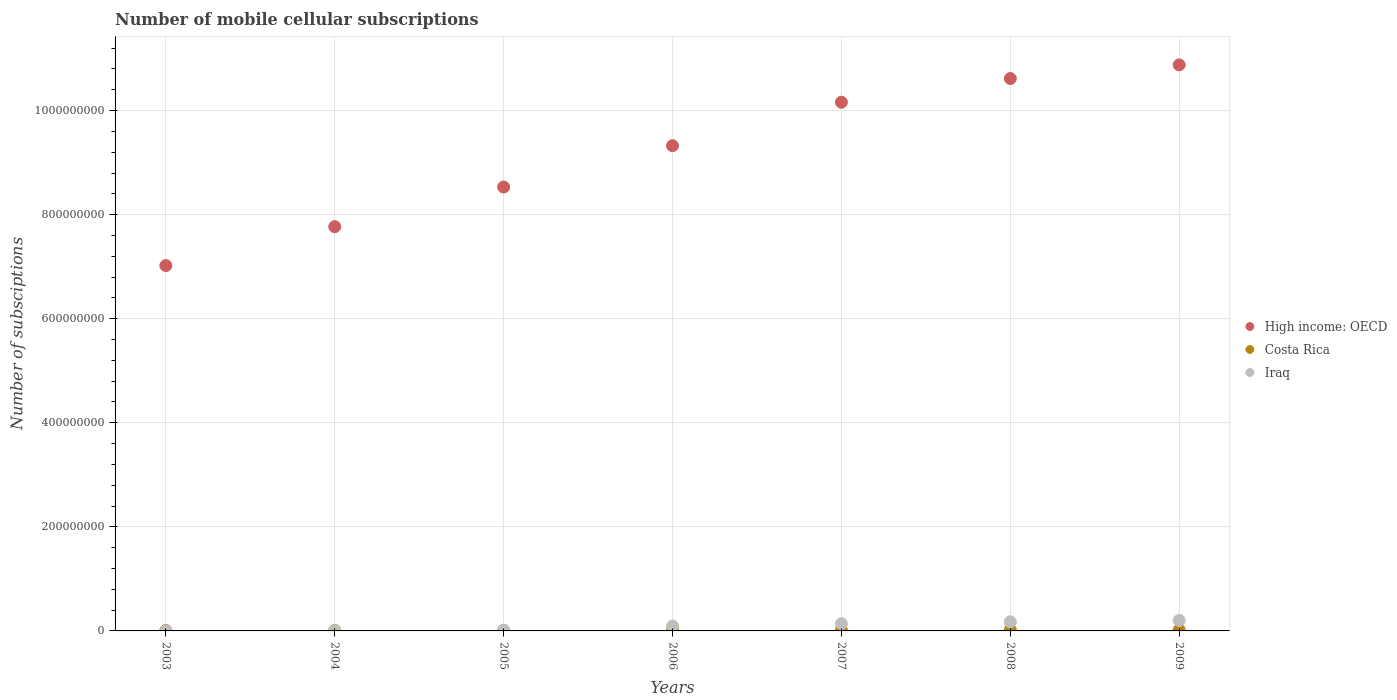What is the number of mobile cellular subscriptions in Costa Rica in 2005?
Give a very brief answer. 1.10e+06. Across all years, what is the maximum number of mobile cellular subscriptions in Iraq?
Keep it short and to the point. 2.01e+07. Across all years, what is the minimum number of mobile cellular subscriptions in Costa Rica?
Your response must be concise. 7.78e+05. In which year was the number of mobile cellular subscriptions in Iraq minimum?
Provide a short and direct response. 2003. What is the total number of mobile cellular subscriptions in High income: OECD in the graph?
Keep it short and to the point. 6.43e+09. What is the difference between the number of mobile cellular subscriptions in Iraq in 2004 and that in 2008?
Your answer should be very brief. -1.70e+07. What is the difference between the number of mobile cellular subscriptions in Iraq in 2003 and the number of mobile cellular subscriptions in Costa Rica in 2009?
Give a very brief answer. -1.87e+06. What is the average number of mobile cellular subscriptions in Iraq per year?
Offer a terse response. 9.03e+06. In the year 2007, what is the difference between the number of mobile cellular subscriptions in Iraq and number of mobile cellular subscriptions in High income: OECD?
Keep it short and to the point. -1.00e+09. What is the ratio of the number of mobile cellular subscriptions in Costa Rica in 2006 to that in 2008?
Ensure brevity in your answer.  0.77. Is the number of mobile cellular subscriptions in Iraq in 2003 less than that in 2006?
Provide a short and direct response. Yes. What is the difference between the highest and the second highest number of mobile cellular subscriptions in Iraq?
Offer a terse response. 2.59e+06. What is the difference between the highest and the lowest number of mobile cellular subscriptions in High income: OECD?
Your answer should be compact. 3.86e+08. Is it the case that in every year, the sum of the number of mobile cellular subscriptions in Costa Rica and number of mobile cellular subscriptions in Iraq  is greater than the number of mobile cellular subscriptions in High income: OECD?
Ensure brevity in your answer.  No. Does the number of mobile cellular subscriptions in Costa Rica monotonically increase over the years?
Ensure brevity in your answer.  Yes. Are the values on the major ticks of Y-axis written in scientific E-notation?
Your answer should be very brief. No. Does the graph contain grids?
Offer a very short reply. Yes. Where does the legend appear in the graph?
Make the answer very short. Center right. How many legend labels are there?
Make the answer very short. 3. What is the title of the graph?
Your answer should be very brief. Number of mobile cellular subscriptions. What is the label or title of the X-axis?
Your answer should be very brief. Years. What is the label or title of the Y-axis?
Your response must be concise. Number of subsciptions. What is the Number of subsciptions of High income: OECD in 2003?
Your answer should be very brief. 7.02e+08. What is the Number of subsciptions of Costa Rica in 2003?
Give a very brief answer. 7.78e+05. What is the Number of subsciptions of Iraq in 2003?
Provide a succinct answer. 8.00e+04. What is the Number of subsciptions in High income: OECD in 2004?
Your answer should be compact. 7.77e+08. What is the Number of subsciptions of Costa Rica in 2004?
Your answer should be compact. 9.23e+05. What is the Number of subsciptions in Iraq in 2004?
Make the answer very short. 5.74e+05. What is the Number of subsciptions in High income: OECD in 2005?
Keep it short and to the point. 8.53e+08. What is the Number of subsciptions of Costa Rica in 2005?
Provide a short and direct response. 1.10e+06. What is the Number of subsciptions in Iraq in 2005?
Your response must be concise. 1.53e+06. What is the Number of subsciptions in High income: OECD in 2006?
Your answer should be compact. 9.33e+08. What is the Number of subsciptions in Costa Rica in 2006?
Ensure brevity in your answer.  1.44e+06. What is the Number of subsciptions in Iraq in 2006?
Your answer should be compact. 9.35e+06. What is the Number of subsciptions in High income: OECD in 2007?
Offer a terse response. 1.02e+09. What is the Number of subsciptions of Costa Rica in 2007?
Keep it short and to the point. 1.51e+06. What is the Number of subsciptions of Iraq in 2007?
Your response must be concise. 1.40e+07. What is the Number of subsciptions of High income: OECD in 2008?
Your answer should be compact. 1.06e+09. What is the Number of subsciptions in Costa Rica in 2008?
Ensure brevity in your answer.  1.89e+06. What is the Number of subsciptions of Iraq in 2008?
Your answer should be very brief. 1.75e+07. What is the Number of subsciptions of High income: OECD in 2009?
Provide a succinct answer. 1.09e+09. What is the Number of subsciptions of Costa Rica in 2009?
Offer a very short reply. 1.95e+06. What is the Number of subsciptions in Iraq in 2009?
Your response must be concise. 2.01e+07. Across all years, what is the maximum Number of subsciptions of High income: OECD?
Make the answer very short. 1.09e+09. Across all years, what is the maximum Number of subsciptions in Costa Rica?
Your response must be concise. 1.95e+06. Across all years, what is the maximum Number of subsciptions in Iraq?
Keep it short and to the point. 2.01e+07. Across all years, what is the minimum Number of subsciptions of High income: OECD?
Ensure brevity in your answer.  7.02e+08. Across all years, what is the minimum Number of subsciptions of Costa Rica?
Provide a succinct answer. 7.78e+05. Across all years, what is the minimum Number of subsciptions of Iraq?
Your answer should be very brief. 8.00e+04. What is the total Number of subsciptions of High income: OECD in the graph?
Make the answer very short. 6.43e+09. What is the total Number of subsciptions of Costa Rica in the graph?
Ensure brevity in your answer.  9.59e+06. What is the total Number of subsciptions of Iraq in the graph?
Offer a very short reply. 6.32e+07. What is the difference between the Number of subsciptions of High income: OECD in 2003 and that in 2004?
Offer a very short reply. -7.48e+07. What is the difference between the Number of subsciptions of Costa Rica in 2003 and that in 2004?
Keep it short and to the point. -1.45e+05. What is the difference between the Number of subsciptions in Iraq in 2003 and that in 2004?
Offer a terse response. -4.94e+05. What is the difference between the Number of subsciptions in High income: OECD in 2003 and that in 2005?
Your answer should be very brief. -1.51e+08. What is the difference between the Number of subsciptions in Costa Rica in 2003 and that in 2005?
Ensure brevity in your answer.  -3.23e+05. What is the difference between the Number of subsciptions in Iraq in 2003 and that in 2005?
Ensure brevity in your answer.  -1.45e+06. What is the difference between the Number of subsciptions of High income: OECD in 2003 and that in 2006?
Keep it short and to the point. -2.30e+08. What is the difference between the Number of subsciptions of Costa Rica in 2003 and that in 2006?
Offer a very short reply. -6.65e+05. What is the difference between the Number of subsciptions of Iraq in 2003 and that in 2006?
Give a very brief answer. -9.27e+06. What is the difference between the Number of subsciptions in High income: OECD in 2003 and that in 2007?
Offer a terse response. -3.14e+08. What is the difference between the Number of subsciptions in Costa Rica in 2003 and that in 2007?
Ensure brevity in your answer.  -7.30e+05. What is the difference between the Number of subsciptions of Iraq in 2003 and that in 2007?
Keep it short and to the point. -1.39e+07. What is the difference between the Number of subsciptions in High income: OECD in 2003 and that in 2008?
Give a very brief answer. -3.59e+08. What is the difference between the Number of subsciptions in Costa Rica in 2003 and that in 2008?
Provide a short and direct response. -1.11e+06. What is the difference between the Number of subsciptions of Iraq in 2003 and that in 2008?
Keep it short and to the point. -1.74e+07. What is the difference between the Number of subsciptions of High income: OECD in 2003 and that in 2009?
Your response must be concise. -3.86e+08. What is the difference between the Number of subsciptions of Costa Rica in 2003 and that in 2009?
Keep it short and to the point. -1.17e+06. What is the difference between the Number of subsciptions in Iraq in 2003 and that in 2009?
Provide a short and direct response. -2.00e+07. What is the difference between the Number of subsciptions in High income: OECD in 2004 and that in 2005?
Keep it short and to the point. -7.62e+07. What is the difference between the Number of subsciptions of Costa Rica in 2004 and that in 2005?
Your answer should be compact. -1.78e+05. What is the difference between the Number of subsciptions in Iraq in 2004 and that in 2005?
Offer a very short reply. -9.59e+05. What is the difference between the Number of subsciptions of High income: OECD in 2004 and that in 2006?
Ensure brevity in your answer.  -1.56e+08. What is the difference between the Number of subsciptions in Costa Rica in 2004 and that in 2006?
Provide a short and direct response. -5.21e+05. What is the difference between the Number of subsciptions in Iraq in 2004 and that in 2006?
Keep it short and to the point. -8.77e+06. What is the difference between the Number of subsciptions in High income: OECD in 2004 and that in 2007?
Your answer should be compact. -2.39e+08. What is the difference between the Number of subsciptions of Costa Rica in 2004 and that in 2007?
Provide a short and direct response. -5.85e+05. What is the difference between the Number of subsciptions in Iraq in 2004 and that in 2007?
Your answer should be very brief. -1.34e+07. What is the difference between the Number of subsciptions in High income: OECD in 2004 and that in 2008?
Ensure brevity in your answer.  -2.85e+08. What is the difference between the Number of subsciptions in Costa Rica in 2004 and that in 2008?
Give a very brief answer. -9.63e+05. What is the difference between the Number of subsciptions in Iraq in 2004 and that in 2008?
Your answer should be very brief. -1.70e+07. What is the difference between the Number of subsciptions in High income: OECD in 2004 and that in 2009?
Offer a terse response. -3.11e+08. What is the difference between the Number of subsciptions of Costa Rica in 2004 and that in 2009?
Make the answer very short. -1.03e+06. What is the difference between the Number of subsciptions of Iraq in 2004 and that in 2009?
Give a very brief answer. -1.95e+07. What is the difference between the Number of subsciptions of High income: OECD in 2005 and that in 2006?
Offer a very short reply. -7.94e+07. What is the difference between the Number of subsciptions of Costa Rica in 2005 and that in 2006?
Your answer should be very brief. -3.42e+05. What is the difference between the Number of subsciptions of Iraq in 2005 and that in 2006?
Ensure brevity in your answer.  -7.81e+06. What is the difference between the Number of subsciptions in High income: OECD in 2005 and that in 2007?
Make the answer very short. -1.63e+08. What is the difference between the Number of subsciptions in Costa Rica in 2005 and that in 2007?
Ensure brevity in your answer.  -4.07e+05. What is the difference between the Number of subsciptions in Iraq in 2005 and that in 2007?
Keep it short and to the point. -1.25e+07. What is the difference between the Number of subsciptions of High income: OECD in 2005 and that in 2008?
Ensure brevity in your answer.  -2.09e+08. What is the difference between the Number of subsciptions in Costa Rica in 2005 and that in 2008?
Offer a terse response. -7.85e+05. What is the difference between the Number of subsciptions of Iraq in 2005 and that in 2008?
Keep it short and to the point. -1.60e+07. What is the difference between the Number of subsciptions of High income: OECD in 2005 and that in 2009?
Ensure brevity in your answer.  -2.35e+08. What is the difference between the Number of subsciptions in Costa Rica in 2005 and that in 2009?
Provide a short and direct response. -8.49e+05. What is the difference between the Number of subsciptions in Iraq in 2005 and that in 2009?
Your answer should be compact. -1.86e+07. What is the difference between the Number of subsciptions in High income: OECD in 2006 and that in 2007?
Your answer should be compact. -8.35e+07. What is the difference between the Number of subsciptions of Costa Rica in 2006 and that in 2007?
Offer a terse response. -6.45e+04. What is the difference between the Number of subsciptions of Iraq in 2006 and that in 2007?
Ensure brevity in your answer.  -4.68e+06. What is the difference between the Number of subsciptions in High income: OECD in 2006 and that in 2008?
Your answer should be compact. -1.29e+08. What is the difference between the Number of subsciptions in Costa Rica in 2006 and that in 2008?
Make the answer very short. -4.43e+05. What is the difference between the Number of subsciptions in Iraq in 2006 and that in 2008?
Your answer should be very brief. -8.18e+06. What is the difference between the Number of subsciptions of High income: OECD in 2006 and that in 2009?
Offer a terse response. -1.55e+08. What is the difference between the Number of subsciptions in Costa Rica in 2006 and that in 2009?
Provide a short and direct response. -5.07e+05. What is the difference between the Number of subsciptions of Iraq in 2006 and that in 2009?
Offer a very short reply. -1.08e+07. What is the difference between the Number of subsciptions of High income: OECD in 2007 and that in 2008?
Make the answer very short. -4.56e+07. What is the difference between the Number of subsciptions of Costa Rica in 2007 and that in 2008?
Offer a terse response. -3.78e+05. What is the difference between the Number of subsciptions of Iraq in 2007 and that in 2008?
Your answer should be compact. -3.51e+06. What is the difference between the Number of subsciptions of High income: OECD in 2007 and that in 2009?
Make the answer very short. -7.18e+07. What is the difference between the Number of subsciptions in Costa Rica in 2007 and that in 2009?
Offer a terse response. -4.42e+05. What is the difference between the Number of subsciptions of Iraq in 2007 and that in 2009?
Provide a short and direct response. -6.10e+06. What is the difference between the Number of subsciptions of High income: OECD in 2008 and that in 2009?
Provide a short and direct response. -2.62e+07. What is the difference between the Number of subsciptions of Costa Rica in 2008 and that in 2009?
Offer a terse response. -6.37e+04. What is the difference between the Number of subsciptions in Iraq in 2008 and that in 2009?
Your answer should be very brief. -2.59e+06. What is the difference between the Number of subsciptions of High income: OECD in 2003 and the Number of subsciptions of Costa Rica in 2004?
Ensure brevity in your answer.  7.01e+08. What is the difference between the Number of subsciptions in High income: OECD in 2003 and the Number of subsciptions in Iraq in 2004?
Provide a short and direct response. 7.02e+08. What is the difference between the Number of subsciptions of Costa Rica in 2003 and the Number of subsciptions of Iraq in 2004?
Keep it short and to the point. 2.04e+05. What is the difference between the Number of subsciptions of High income: OECD in 2003 and the Number of subsciptions of Costa Rica in 2005?
Your response must be concise. 7.01e+08. What is the difference between the Number of subsciptions in High income: OECD in 2003 and the Number of subsciptions in Iraq in 2005?
Provide a succinct answer. 7.01e+08. What is the difference between the Number of subsciptions of Costa Rica in 2003 and the Number of subsciptions of Iraq in 2005?
Provide a short and direct response. -7.55e+05. What is the difference between the Number of subsciptions in High income: OECD in 2003 and the Number of subsciptions in Costa Rica in 2006?
Offer a very short reply. 7.01e+08. What is the difference between the Number of subsciptions in High income: OECD in 2003 and the Number of subsciptions in Iraq in 2006?
Keep it short and to the point. 6.93e+08. What is the difference between the Number of subsciptions in Costa Rica in 2003 and the Number of subsciptions in Iraq in 2006?
Keep it short and to the point. -8.57e+06. What is the difference between the Number of subsciptions of High income: OECD in 2003 and the Number of subsciptions of Costa Rica in 2007?
Keep it short and to the point. 7.01e+08. What is the difference between the Number of subsciptions in High income: OECD in 2003 and the Number of subsciptions in Iraq in 2007?
Keep it short and to the point. 6.88e+08. What is the difference between the Number of subsciptions in Costa Rica in 2003 and the Number of subsciptions in Iraq in 2007?
Your response must be concise. -1.32e+07. What is the difference between the Number of subsciptions in High income: OECD in 2003 and the Number of subsciptions in Costa Rica in 2008?
Make the answer very short. 7.00e+08. What is the difference between the Number of subsciptions in High income: OECD in 2003 and the Number of subsciptions in Iraq in 2008?
Offer a very short reply. 6.85e+08. What is the difference between the Number of subsciptions of Costa Rica in 2003 and the Number of subsciptions of Iraq in 2008?
Your response must be concise. -1.68e+07. What is the difference between the Number of subsciptions in High income: OECD in 2003 and the Number of subsciptions in Costa Rica in 2009?
Offer a terse response. 7.00e+08. What is the difference between the Number of subsciptions in High income: OECD in 2003 and the Number of subsciptions in Iraq in 2009?
Your response must be concise. 6.82e+08. What is the difference between the Number of subsciptions in Costa Rica in 2003 and the Number of subsciptions in Iraq in 2009?
Your response must be concise. -1.93e+07. What is the difference between the Number of subsciptions of High income: OECD in 2004 and the Number of subsciptions of Costa Rica in 2005?
Your answer should be very brief. 7.76e+08. What is the difference between the Number of subsciptions of High income: OECD in 2004 and the Number of subsciptions of Iraq in 2005?
Offer a terse response. 7.75e+08. What is the difference between the Number of subsciptions of Costa Rica in 2004 and the Number of subsciptions of Iraq in 2005?
Provide a short and direct response. -6.10e+05. What is the difference between the Number of subsciptions of High income: OECD in 2004 and the Number of subsciptions of Costa Rica in 2006?
Keep it short and to the point. 7.76e+08. What is the difference between the Number of subsciptions of High income: OECD in 2004 and the Number of subsciptions of Iraq in 2006?
Offer a terse response. 7.68e+08. What is the difference between the Number of subsciptions in Costa Rica in 2004 and the Number of subsciptions in Iraq in 2006?
Provide a succinct answer. -8.42e+06. What is the difference between the Number of subsciptions in High income: OECD in 2004 and the Number of subsciptions in Costa Rica in 2007?
Provide a succinct answer. 7.75e+08. What is the difference between the Number of subsciptions in High income: OECD in 2004 and the Number of subsciptions in Iraq in 2007?
Your response must be concise. 7.63e+08. What is the difference between the Number of subsciptions of Costa Rica in 2004 and the Number of subsciptions of Iraq in 2007?
Your response must be concise. -1.31e+07. What is the difference between the Number of subsciptions in High income: OECD in 2004 and the Number of subsciptions in Costa Rica in 2008?
Provide a short and direct response. 7.75e+08. What is the difference between the Number of subsciptions in High income: OECD in 2004 and the Number of subsciptions in Iraq in 2008?
Your answer should be compact. 7.59e+08. What is the difference between the Number of subsciptions of Costa Rica in 2004 and the Number of subsciptions of Iraq in 2008?
Your answer should be compact. -1.66e+07. What is the difference between the Number of subsciptions of High income: OECD in 2004 and the Number of subsciptions of Costa Rica in 2009?
Offer a very short reply. 7.75e+08. What is the difference between the Number of subsciptions in High income: OECD in 2004 and the Number of subsciptions in Iraq in 2009?
Provide a short and direct response. 7.57e+08. What is the difference between the Number of subsciptions in Costa Rica in 2004 and the Number of subsciptions in Iraq in 2009?
Ensure brevity in your answer.  -1.92e+07. What is the difference between the Number of subsciptions in High income: OECD in 2005 and the Number of subsciptions in Costa Rica in 2006?
Provide a short and direct response. 8.52e+08. What is the difference between the Number of subsciptions in High income: OECD in 2005 and the Number of subsciptions in Iraq in 2006?
Your answer should be very brief. 8.44e+08. What is the difference between the Number of subsciptions of Costa Rica in 2005 and the Number of subsciptions of Iraq in 2006?
Ensure brevity in your answer.  -8.24e+06. What is the difference between the Number of subsciptions of High income: OECD in 2005 and the Number of subsciptions of Costa Rica in 2007?
Provide a short and direct response. 8.52e+08. What is the difference between the Number of subsciptions in High income: OECD in 2005 and the Number of subsciptions in Iraq in 2007?
Offer a terse response. 8.39e+08. What is the difference between the Number of subsciptions of Costa Rica in 2005 and the Number of subsciptions of Iraq in 2007?
Your response must be concise. -1.29e+07. What is the difference between the Number of subsciptions in High income: OECD in 2005 and the Number of subsciptions in Costa Rica in 2008?
Make the answer very short. 8.51e+08. What is the difference between the Number of subsciptions in High income: OECD in 2005 and the Number of subsciptions in Iraq in 2008?
Your answer should be very brief. 8.36e+08. What is the difference between the Number of subsciptions of Costa Rica in 2005 and the Number of subsciptions of Iraq in 2008?
Your answer should be very brief. -1.64e+07. What is the difference between the Number of subsciptions of High income: OECD in 2005 and the Number of subsciptions of Costa Rica in 2009?
Your response must be concise. 8.51e+08. What is the difference between the Number of subsciptions in High income: OECD in 2005 and the Number of subsciptions in Iraq in 2009?
Offer a terse response. 8.33e+08. What is the difference between the Number of subsciptions of Costa Rica in 2005 and the Number of subsciptions of Iraq in 2009?
Offer a terse response. -1.90e+07. What is the difference between the Number of subsciptions in High income: OECD in 2006 and the Number of subsciptions in Costa Rica in 2007?
Offer a very short reply. 9.31e+08. What is the difference between the Number of subsciptions of High income: OECD in 2006 and the Number of subsciptions of Iraq in 2007?
Offer a terse response. 9.19e+08. What is the difference between the Number of subsciptions of Costa Rica in 2006 and the Number of subsciptions of Iraq in 2007?
Give a very brief answer. -1.26e+07. What is the difference between the Number of subsciptions of High income: OECD in 2006 and the Number of subsciptions of Costa Rica in 2008?
Give a very brief answer. 9.31e+08. What is the difference between the Number of subsciptions of High income: OECD in 2006 and the Number of subsciptions of Iraq in 2008?
Offer a terse response. 9.15e+08. What is the difference between the Number of subsciptions in Costa Rica in 2006 and the Number of subsciptions in Iraq in 2008?
Offer a very short reply. -1.61e+07. What is the difference between the Number of subsciptions of High income: OECD in 2006 and the Number of subsciptions of Costa Rica in 2009?
Your answer should be very brief. 9.31e+08. What is the difference between the Number of subsciptions in High income: OECD in 2006 and the Number of subsciptions in Iraq in 2009?
Your answer should be compact. 9.12e+08. What is the difference between the Number of subsciptions of Costa Rica in 2006 and the Number of subsciptions of Iraq in 2009?
Make the answer very short. -1.87e+07. What is the difference between the Number of subsciptions of High income: OECD in 2007 and the Number of subsciptions of Costa Rica in 2008?
Provide a short and direct response. 1.01e+09. What is the difference between the Number of subsciptions in High income: OECD in 2007 and the Number of subsciptions in Iraq in 2008?
Provide a succinct answer. 9.99e+08. What is the difference between the Number of subsciptions of Costa Rica in 2007 and the Number of subsciptions of Iraq in 2008?
Keep it short and to the point. -1.60e+07. What is the difference between the Number of subsciptions in High income: OECD in 2007 and the Number of subsciptions in Costa Rica in 2009?
Provide a succinct answer. 1.01e+09. What is the difference between the Number of subsciptions of High income: OECD in 2007 and the Number of subsciptions of Iraq in 2009?
Offer a very short reply. 9.96e+08. What is the difference between the Number of subsciptions of Costa Rica in 2007 and the Number of subsciptions of Iraq in 2009?
Offer a very short reply. -1.86e+07. What is the difference between the Number of subsciptions of High income: OECD in 2008 and the Number of subsciptions of Costa Rica in 2009?
Provide a succinct answer. 1.06e+09. What is the difference between the Number of subsciptions in High income: OECD in 2008 and the Number of subsciptions in Iraq in 2009?
Make the answer very short. 1.04e+09. What is the difference between the Number of subsciptions of Costa Rica in 2008 and the Number of subsciptions of Iraq in 2009?
Offer a very short reply. -1.82e+07. What is the average Number of subsciptions in High income: OECD per year?
Provide a succinct answer. 9.19e+08. What is the average Number of subsciptions in Costa Rica per year?
Provide a short and direct response. 1.37e+06. What is the average Number of subsciptions of Iraq per year?
Your response must be concise. 9.03e+06. In the year 2003, what is the difference between the Number of subsciptions of High income: OECD and Number of subsciptions of Costa Rica?
Make the answer very short. 7.01e+08. In the year 2003, what is the difference between the Number of subsciptions in High income: OECD and Number of subsciptions in Iraq?
Offer a terse response. 7.02e+08. In the year 2003, what is the difference between the Number of subsciptions in Costa Rica and Number of subsciptions in Iraq?
Provide a succinct answer. 6.98e+05. In the year 2004, what is the difference between the Number of subsciptions in High income: OECD and Number of subsciptions in Costa Rica?
Ensure brevity in your answer.  7.76e+08. In the year 2004, what is the difference between the Number of subsciptions in High income: OECD and Number of subsciptions in Iraq?
Ensure brevity in your answer.  7.76e+08. In the year 2004, what is the difference between the Number of subsciptions of Costa Rica and Number of subsciptions of Iraq?
Your answer should be very brief. 3.49e+05. In the year 2005, what is the difference between the Number of subsciptions of High income: OECD and Number of subsciptions of Costa Rica?
Keep it short and to the point. 8.52e+08. In the year 2005, what is the difference between the Number of subsciptions in High income: OECD and Number of subsciptions in Iraq?
Give a very brief answer. 8.52e+08. In the year 2005, what is the difference between the Number of subsciptions of Costa Rica and Number of subsciptions of Iraq?
Your answer should be compact. -4.32e+05. In the year 2006, what is the difference between the Number of subsciptions in High income: OECD and Number of subsciptions in Costa Rica?
Provide a succinct answer. 9.31e+08. In the year 2006, what is the difference between the Number of subsciptions in High income: OECD and Number of subsciptions in Iraq?
Keep it short and to the point. 9.23e+08. In the year 2006, what is the difference between the Number of subsciptions in Costa Rica and Number of subsciptions in Iraq?
Your answer should be very brief. -7.90e+06. In the year 2007, what is the difference between the Number of subsciptions of High income: OECD and Number of subsciptions of Costa Rica?
Provide a short and direct response. 1.01e+09. In the year 2007, what is the difference between the Number of subsciptions in High income: OECD and Number of subsciptions in Iraq?
Give a very brief answer. 1.00e+09. In the year 2007, what is the difference between the Number of subsciptions of Costa Rica and Number of subsciptions of Iraq?
Offer a terse response. -1.25e+07. In the year 2008, what is the difference between the Number of subsciptions in High income: OECD and Number of subsciptions in Costa Rica?
Your response must be concise. 1.06e+09. In the year 2008, what is the difference between the Number of subsciptions of High income: OECD and Number of subsciptions of Iraq?
Ensure brevity in your answer.  1.04e+09. In the year 2008, what is the difference between the Number of subsciptions of Costa Rica and Number of subsciptions of Iraq?
Ensure brevity in your answer.  -1.56e+07. In the year 2009, what is the difference between the Number of subsciptions of High income: OECD and Number of subsciptions of Costa Rica?
Offer a terse response. 1.09e+09. In the year 2009, what is the difference between the Number of subsciptions of High income: OECD and Number of subsciptions of Iraq?
Your answer should be compact. 1.07e+09. In the year 2009, what is the difference between the Number of subsciptions of Costa Rica and Number of subsciptions of Iraq?
Offer a very short reply. -1.82e+07. What is the ratio of the Number of subsciptions in High income: OECD in 2003 to that in 2004?
Offer a terse response. 0.9. What is the ratio of the Number of subsciptions in Costa Rica in 2003 to that in 2004?
Give a very brief answer. 0.84. What is the ratio of the Number of subsciptions of Iraq in 2003 to that in 2004?
Your answer should be very brief. 0.14. What is the ratio of the Number of subsciptions of High income: OECD in 2003 to that in 2005?
Your response must be concise. 0.82. What is the ratio of the Number of subsciptions of Costa Rica in 2003 to that in 2005?
Offer a very short reply. 0.71. What is the ratio of the Number of subsciptions of Iraq in 2003 to that in 2005?
Provide a short and direct response. 0.05. What is the ratio of the Number of subsciptions of High income: OECD in 2003 to that in 2006?
Your response must be concise. 0.75. What is the ratio of the Number of subsciptions of Costa Rica in 2003 to that in 2006?
Your answer should be very brief. 0.54. What is the ratio of the Number of subsciptions in Iraq in 2003 to that in 2006?
Ensure brevity in your answer.  0.01. What is the ratio of the Number of subsciptions in High income: OECD in 2003 to that in 2007?
Provide a succinct answer. 0.69. What is the ratio of the Number of subsciptions of Costa Rica in 2003 to that in 2007?
Your answer should be very brief. 0.52. What is the ratio of the Number of subsciptions in Iraq in 2003 to that in 2007?
Keep it short and to the point. 0.01. What is the ratio of the Number of subsciptions of High income: OECD in 2003 to that in 2008?
Make the answer very short. 0.66. What is the ratio of the Number of subsciptions in Costa Rica in 2003 to that in 2008?
Give a very brief answer. 0.41. What is the ratio of the Number of subsciptions in Iraq in 2003 to that in 2008?
Offer a very short reply. 0. What is the ratio of the Number of subsciptions in High income: OECD in 2003 to that in 2009?
Keep it short and to the point. 0.65. What is the ratio of the Number of subsciptions in Costa Rica in 2003 to that in 2009?
Make the answer very short. 0.4. What is the ratio of the Number of subsciptions in Iraq in 2003 to that in 2009?
Provide a succinct answer. 0. What is the ratio of the Number of subsciptions in High income: OECD in 2004 to that in 2005?
Your answer should be compact. 0.91. What is the ratio of the Number of subsciptions of Costa Rica in 2004 to that in 2005?
Your answer should be very brief. 0.84. What is the ratio of the Number of subsciptions of Iraq in 2004 to that in 2005?
Offer a very short reply. 0.37. What is the ratio of the Number of subsciptions of High income: OECD in 2004 to that in 2006?
Offer a terse response. 0.83. What is the ratio of the Number of subsciptions of Costa Rica in 2004 to that in 2006?
Give a very brief answer. 0.64. What is the ratio of the Number of subsciptions of Iraq in 2004 to that in 2006?
Your response must be concise. 0.06. What is the ratio of the Number of subsciptions in High income: OECD in 2004 to that in 2007?
Your answer should be compact. 0.76. What is the ratio of the Number of subsciptions in Costa Rica in 2004 to that in 2007?
Your answer should be compact. 0.61. What is the ratio of the Number of subsciptions of Iraq in 2004 to that in 2007?
Keep it short and to the point. 0.04. What is the ratio of the Number of subsciptions in High income: OECD in 2004 to that in 2008?
Your answer should be very brief. 0.73. What is the ratio of the Number of subsciptions in Costa Rica in 2004 to that in 2008?
Ensure brevity in your answer.  0.49. What is the ratio of the Number of subsciptions in Iraq in 2004 to that in 2008?
Your answer should be compact. 0.03. What is the ratio of the Number of subsciptions in High income: OECD in 2004 to that in 2009?
Provide a short and direct response. 0.71. What is the ratio of the Number of subsciptions in Costa Rica in 2004 to that in 2009?
Provide a short and direct response. 0.47. What is the ratio of the Number of subsciptions in Iraq in 2004 to that in 2009?
Ensure brevity in your answer.  0.03. What is the ratio of the Number of subsciptions in High income: OECD in 2005 to that in 2006?
Ensure brevity in your answer.  0.91. What is the ratio of the Number of subsciptions of Costa Rica in 2005 to that in 2006?
Ensure brevity in your answer.  0.76. What is the ratio of the Number of subsciptions of Iraq in 2005 to that in 2006?
Your answer should be compact. 0.16. What is the ratio of the Number of subsciptions of High income: OECD in 2005 to that in 2007?
Your answer should be very brief. 0.84. What is the ratio of the Number of subsciptions of Costa Rica in 2005 to that in 2007?
Your response must be concise. 0.73. What is the ratio of the Number of subsciptions in Iraq in 2005 to that in 2007?
Offer a terse response. 0.11. What is the ratio of the Number of subsciptions in High income: OECD in 2005 to that in 2008?
Your answer should be compact. 0.8. What is the ratio of the Number of subsciptions of Costa Rica in 2005 to that in 2008?
Offer a terse response. 0.58. What is the ratio of the Number of subsciptions of Iraq in 2005 to that in 2008?
Offer a very short reply. 0.09. What is the ratio of the Number of subsciptions of High income: OECD in 2005 to that in 2009?
Provide a short and direct response. 0.78. What is the ratio of the Number of subsciptions of Costa Rica in 2005 to that in 2009?
Make the answer very short. 0.56. What is the ratio of the Number of subsciptions of Iraq in 2005 to that in 2009?
Your answer should be compact. 0.08. What is the ratio of the Number of subsciptions in High income: OECD in 2006 to that in 2007?
Provide a succinct answer. 0.92. What is the ratio of the Number of subsciptions in Costa Rica in 2006 to that in 2007?
Give a very brief answer. 0.96. What is the ratio of the Number of subsciptions of Iraq in 2006 to that in 2007?
Offer a terse response. 0.67. What is the ratio of the Number of subsciptions in High income: OECD in 2006 to that in 2008?
Your answer should be very brief. 0.88. What is the ratio of the Number of subsciptions of Costa Rica in 2006 to that in 2008?
Give a very brief answer. 0.77. What is the ratio of the Number of subsciptions in Iraq in 2006 to that in 2008?
Your response must be concise. 0.53. What is the ratio of the Number of subsciptions of High income: OECD in 2006 to that in 2009?
Offer a very short reply. 0.86. What is the ratio of the Number of subsciptions of Costa Rica in 2006 to that in 2009?
Your answer should be very brief. 0.74. What is the ratio of the Number of subsciptions in Iraq in 2006 to that in 2009?
Offer a terse response. 0.46. What is the ratio of the Number of subsciptions of Costa Rica in 2007 to that in 2008?
Offer a very short reply. 0.8. What is the ratio of the Number of subsciptions in Iraq in 2007 to that in 2008?
Provide a short and direct response. 0.8. What is the ratio of the Number of subsciptions of High income: OECD in 2007 to that in 2009?
Provide a short and direct response. 0.93. What is the ratio of the Number of subsciptions of Costa Rica in 2007 to that in 2009?
Your answer should be very brief. 0.77. What is the ratio of the Number of subsciptions of Iraq in 2007 to that in 2009?
Give a very brief answer. 0.7. What is the ratio of the Number of subsciptions in High income: OECD in 2008 to that in 2009?
Keep it short and to the point. 0.98. What is the ratio of the Number of subsciptions of Costa Rica in 2008 to that in 2009?
Keep it short and to the point. 0.97. What is the ratio of the Number of subsciptions in Iraq in 2008 to that in 2009?
Offer a very short reply. 0.87. What is the difference between the highest and the second highest Number of subsciptions of High income: OECD?
Give a very brief answer. 2.62e+07. What is the difference between the highest and the second highest Number of subsciptions in Costa Rica?
Your response must be concise. 6.37e+04. What is the difference between the highest and the second highest Number of subsciptions of Iraq?
Your answer should be very brief. 2.59e+06. What is the difference between the highest and the lowest Number of subsciptions of High income: OECD?
Ensure brevity in your answer.  3.86e+08. What is the difference between the highest and the lowest Number of subsciptions of Costa Rica?
Offer a terse response. 1.17e+06. What is the difference between the highest and the lowest Number of subsciptions in Iraq?
Give a very brief answer. 2.00e+07. 